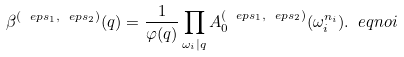<formula> <loc_0><loc_0><loc_500><loc_500>\beta ^ { ( \ e p s _ { 1 } , \ e p s _ { 2 } ) } ( q ) = \frac { 1 } { \varphi ( q ) } \prod _ { \omega _ { i } | q } A ^ { ( \ e p s _ { 1 } , \ e p s _ { 2 } ) } _ { 0 } ( \omega _ { i } ^ { n _ { i } } ) . \ e q n o i</formula> 